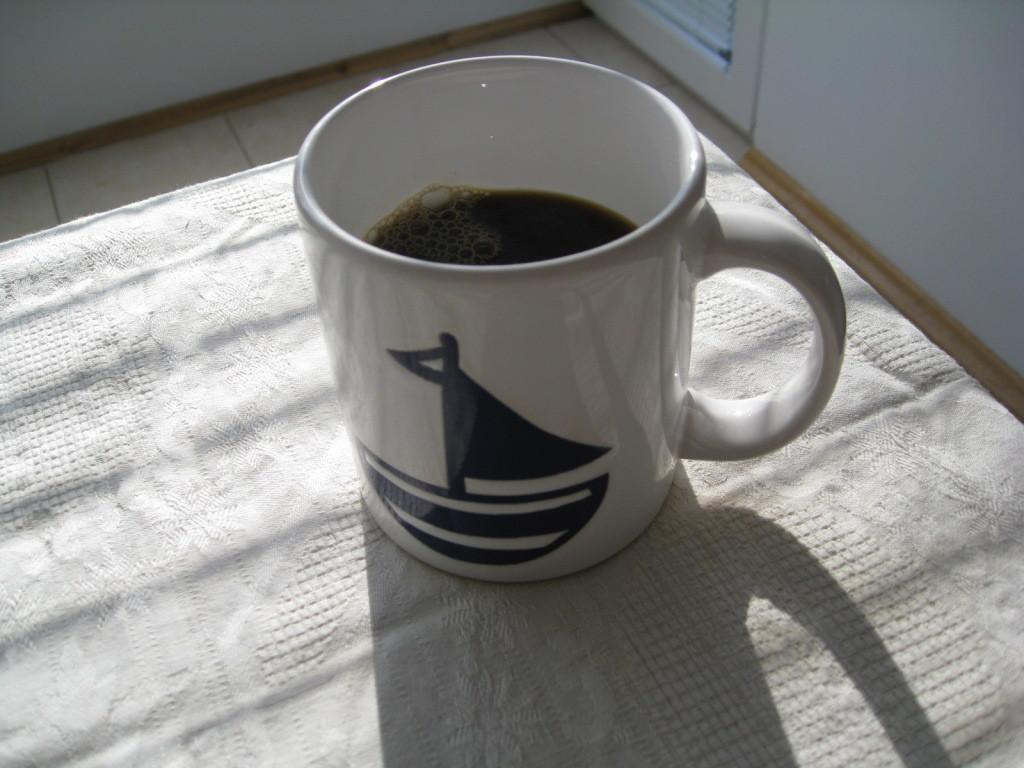What is in the cup that is visible in the image? There is a drink in the cup that is visible in the image. What is the cup placed on? The cup is on a cloth. What type of surface is visible beneath the cloth? There is a floor visible in the image. What type of architectural feature can be seen in the image? There is a wall and a door in the image. What type of instrument is being played in the image? There is no instrument being played in the image. Can you describe the sidewalk in the image? There is no sidewalk present in the image. 